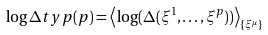Convert formula to latex. <formula><loc_0><loc_0><loc_500><loc_500>\log \Delta t y p ( p ) = \left < \log ( \Delta ( \xi ^ { 1 } , \dots , \xi ^ { p } ) ) \right > _ { \{ \xi ^ { \mu } \} }</formula> 